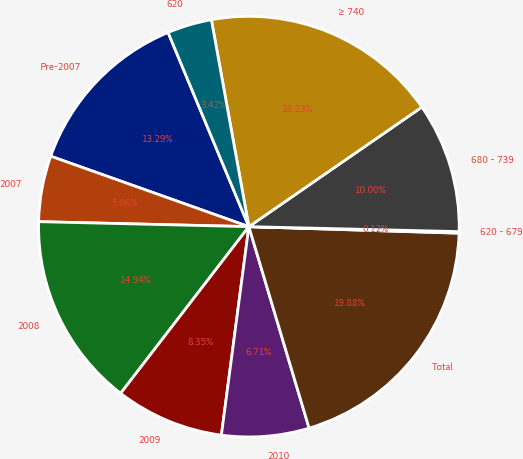Convert chart. <chart><loc_0><loc_0><loc_500><loc_500><pie_chart><fcel>Pre-2007<fcel>2007<fcel>2008<fcel>2009<fcel>2010<fcel>Total<fcel>620 - 679<fcel>680 - 739<fcel>≥ 740<fcel>620<nl><fcel>13.29%<fcel>5.06%<fcel>14.94%<fcel>8.35%<fcel>6.71%<fcel>19.88%<fcel>0.12%<fcel>10.0%<fcel>18.23%<fcel>3.42%<nl></chart> 